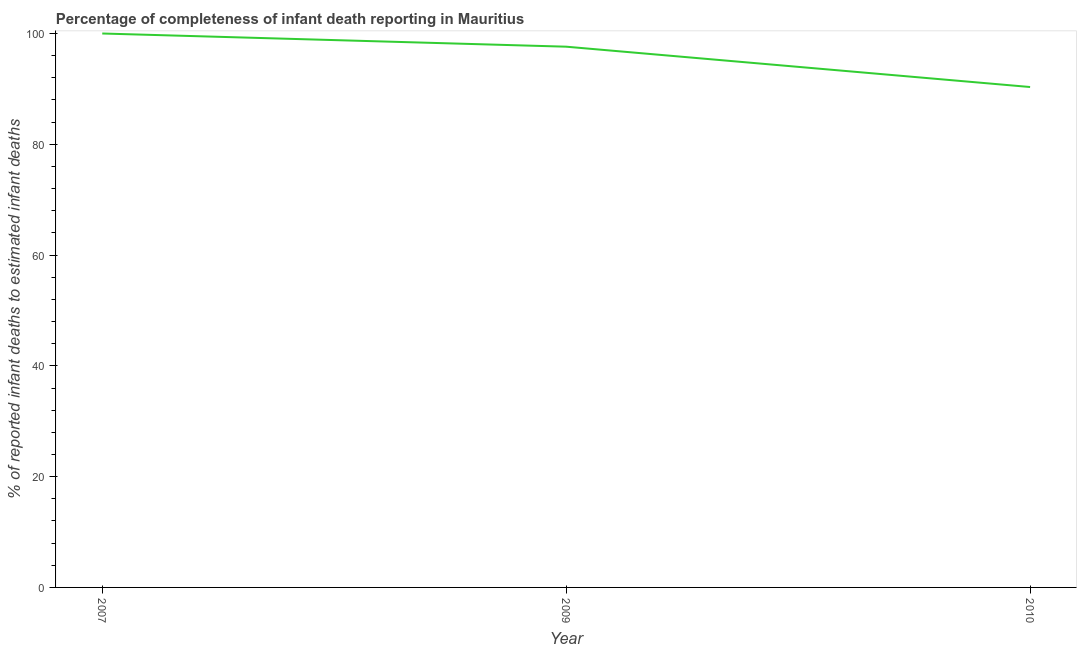What is the completeness of infant death reporting in 2010?
Your answer should be very brief. 90.34. Across all years, what is the minimum completeness of infant death reporting?
Offer a terse response. 90.34. In which year was the completeness of infant death reporting maximum?
Ensure brevity in your answer.  2007. In which year was the completeness of infant death reporting minimum?
Give a very brief answer. 2010. What is the sum of the completeness of infant death reporting?
Ensure brevity in your answer.  287.96. What is the difference between the completeness of infant death reporting in 2009 and 2010?
Provide a short and direct response. 7.28. What is the average completeness of infant death reporting per year?
Your answer should be very brief. 95.99. What is the median completeness of infant death reporting?
Give a very brief answer. 97.62. What is the ratio of the completeness of infant death reporting in 2009 to that in 2010?
Make the answer very short. 1.08. Is the completeness of infant death reporting in 2007 less than that in 2010?
Your answer should be compact. No. What is the difference between the highest and the second highest completeness of infant death reporting?
Your response must be concise. 2.38. What is the difference between the highest and the lowest completeness of infant death reporting?
Make the answer very short. 9.66. Does the completeness of infant death reporting monotonically increase over the years?
Your response must be concise. No. How many lines are there?
Ensure brevity in your answer.  1. What is the difference between two consecutive major ticks on the Y-axis?
Provide a succinct answer. 20. Are the values on the major ticks of Y-axis written in scientific E-notation?
Make the answer very short. No. What is the title of the graph?
Your answer should be compact. Percentage of completeness of infant death reporting in Mauritius. What is the label or title of the Y-axis?
Your answer should be compact. % of reported infant deaths to estimated infant deaths. What is the % of reported infant deaths to estimated infant deaths of 2007?
Offer a terse response. 100. What is the % of reported infant deaths to estimated infant deaths of 2009?
Make the answer very short. 97.62. What is the % of reported infant deaths to estimated infant deaths in 2010?
Your answer should be very brief. 90.34. What is the difference between the % of reported infant deaths to estimated infant deaths in 2007 and 2009?
Provide a short and direct response. 2.38. What is the difference between the % of reported infant deaths to estimated infant deaths in 2007 and 2010?
Offer a very short reply. 9.66. What is the difference between the % of reported infant deaths to estimated infant deaths in 2009 and 2010?
Keep it short and to the point. 7.28. What is the ratio of the % of reported infant deaths to estimated infant deaths in 2007 to that in 2010?
Your response must be concise. 1.11. What is the ratio of the % of reported infant deaths to estimated infant deaths in 2009 to that in 2010?
Give a very brief answer. 1.08. 